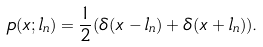<formula> <loc_0><loc_0><loc_500><loc_500>p ( x ; l _ { n } ) = \frac { 1 } { 2 } ( \delta ( x - l _ { n } ) + \delta ( x + l _ { n } ) ) .</formula> 